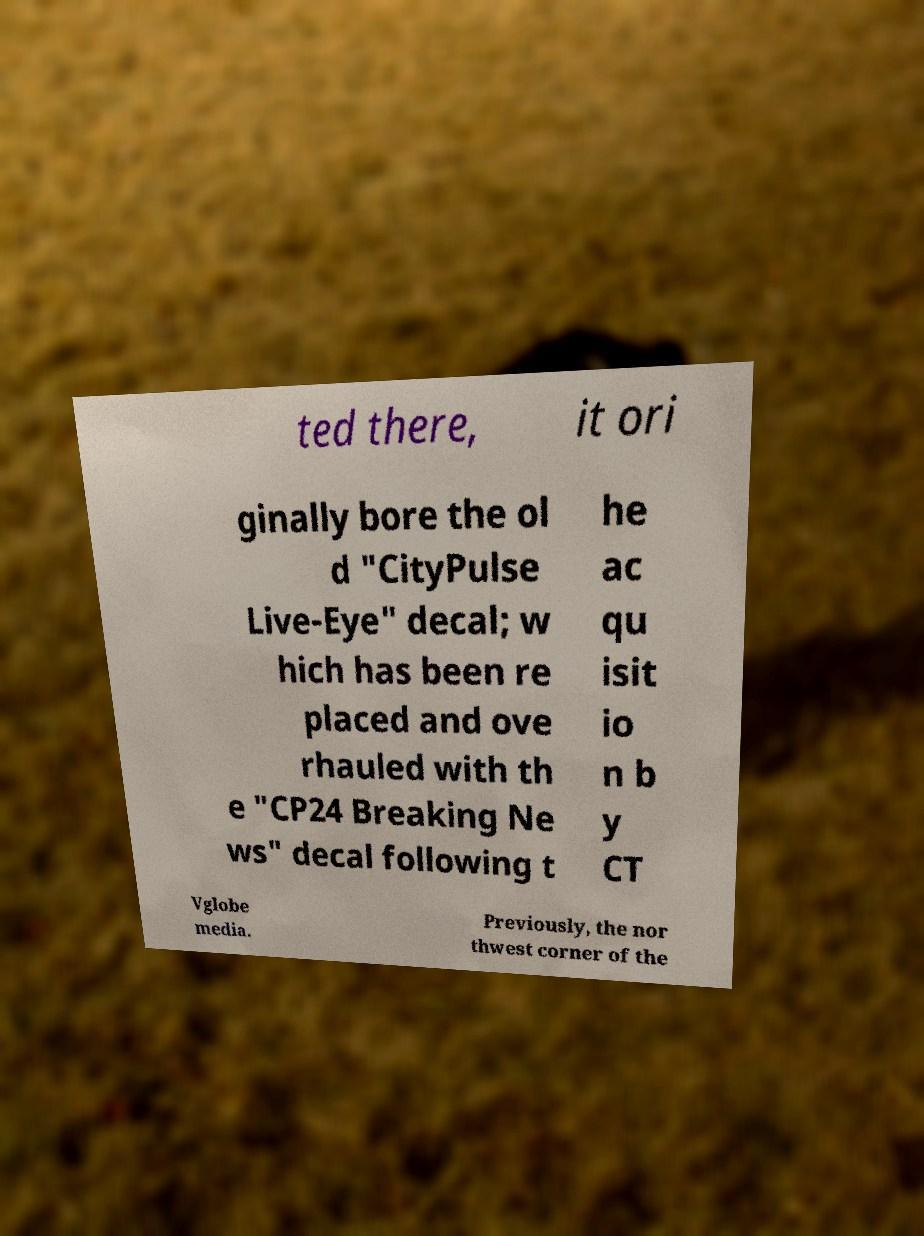There's text embedded in this image that I need extracted. Can you transcribe it verbatim? ted there, it ori ginally bore the ol d "CityPulse Live-Eye" decal; w hich has been re placed and ove rhauled with th e "CP24 Breaking Ne ws" decal following t he ac qu isit io n b y CT Vglobe media. Previously, the nor thwest corner of the 